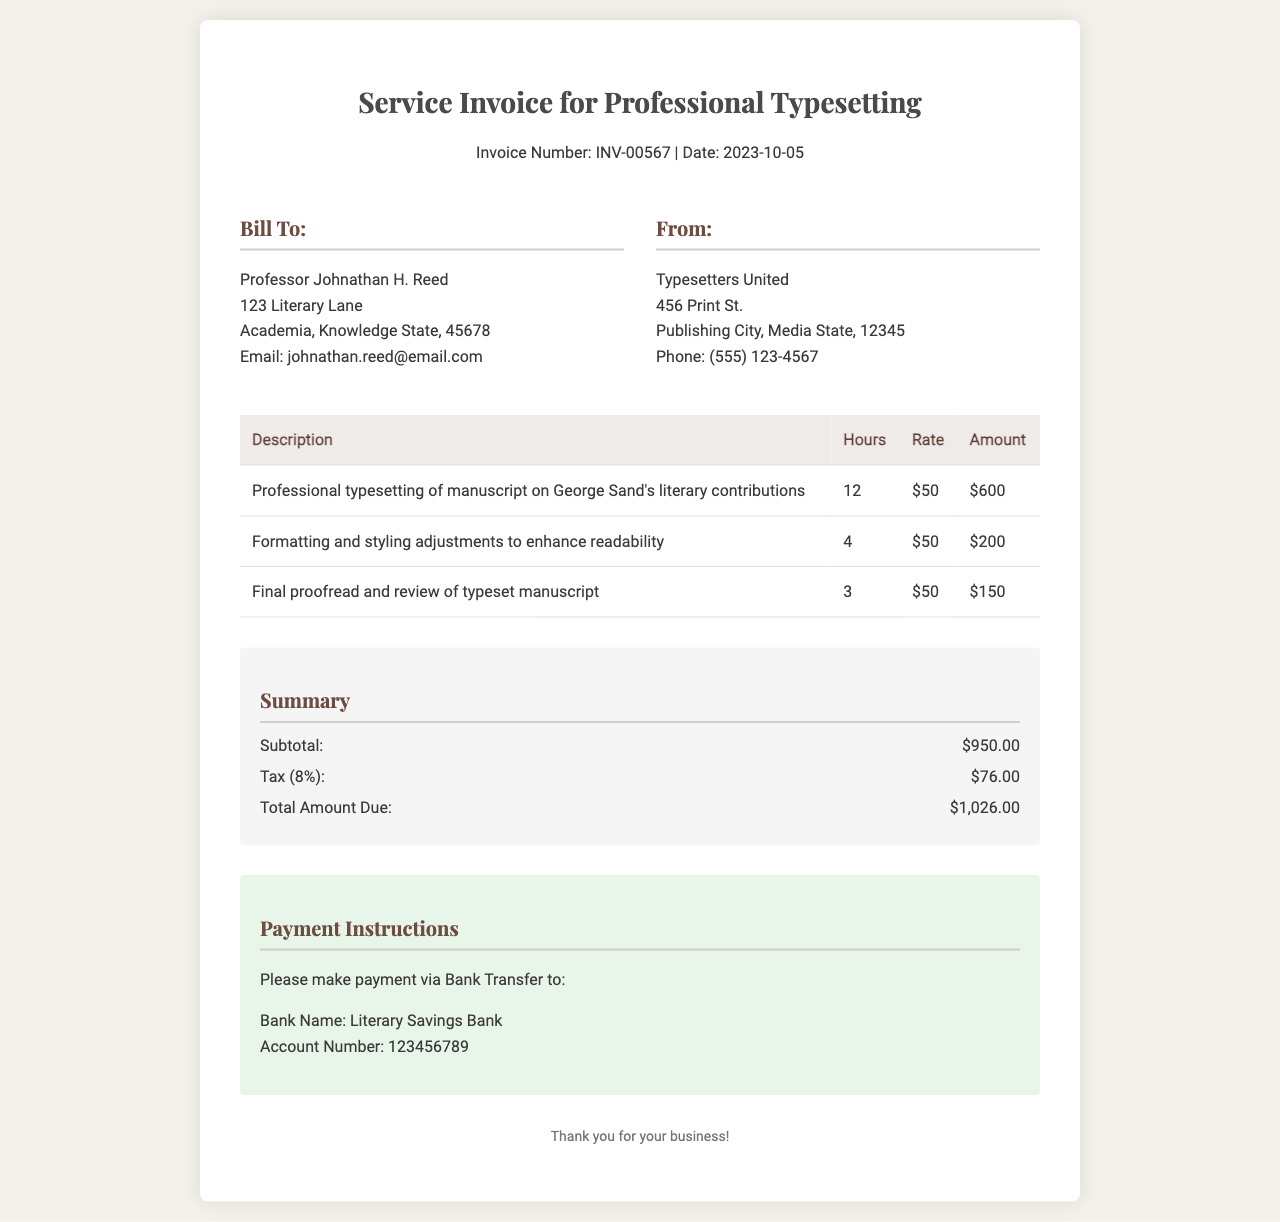What is the invoice number? The invoice number is explicitly stated at the top of the document.
Answer: INV-00567 What is the date of the invoice? The date is provided alongside the invoice number in the header section.
Answer: 2023-10-05 Who is the client? The client's details, including their name, are listed in the 'Bill To' section.
Answer: Professor Johnathan H. Reed How many hours were worked on the manuscript typesetting for George Sand? The hours worked are detailed in the services table.
Answer: 12 What is the total amount due? The total amount is summarized at the bottom of the invoice in the summary section.
Answer: $1,026.00 What was the tax percentage applied? The tax calculation in the summary section indicates the applied tax rate.
Answer: 8% What is the service description for the third line item? The service description is mentioned for each service in the table.
Answer: Final proofread and review of typeset manuscript How much did formatting and styling adjustments cost? The amount for formatting and styling is detailed in the table.
Answer: $200 To which bank should the payment be made? The payment instructions specify the bank to which payment should be sent.
Answer: Literary Savings Bank 